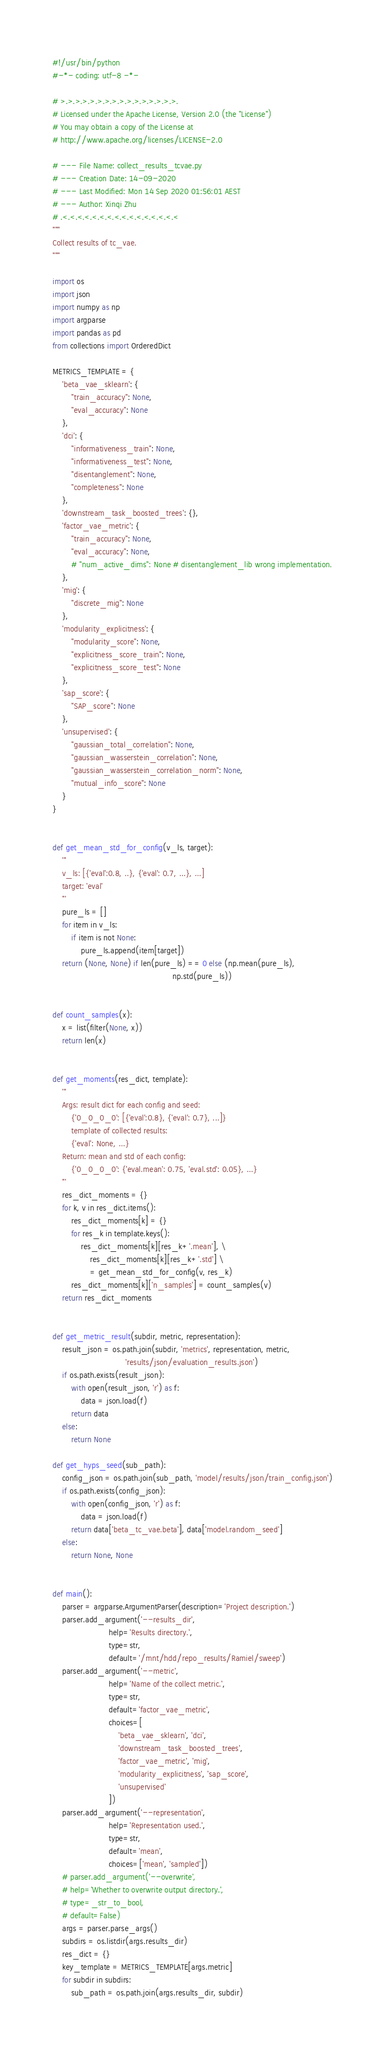Convert code to text. <code><loc_0><loc_0><loc_500><loc_500><_Python_>#!/usr/bin/python
#-*- coding: utf-8 -*-

# >.>.>.>.>.>.>.>.>.>.>.>.>.>.>.>.
# Licensed under the Apache License, Version 2.0 (the "License")
# You may obtain a copy of the License at
# http://www.apache.org/licenses/LICENSE-2.0

# --- File Name: collect_results_tcvae.py
# --- Creation Date: 14-09-2020
# --- Last Modified: Mon 14 Sep 2020 01:56:01 AEST
# --- Author: Xinqi Zhu
# .<.<.<.<.<.<.<.<.<.<.<.<.<.<.<.<
"""
Collect results of tc_vae.
"""

import os
import json
import numpy as np
import argparse
import pandas as pd
from collections import OrderedDict

METRICS_TEMPLATE = {
    'beta_vae_sklearn': {
        "train_accuracy": None,
        "eval_accuracy": None
    },
    'dci': {
        "informativeness_train": None,
        "informativeness_test": None,
        "disentanglement": None,
        "completeness": None
    },
    'downstream_task_boosted_trees': {},
    'factor_vae_metric': {
        "train_accuracy": None,
        "eval_accuracy": None,
        # "num_active_dims": None # disentanglement_lib wrong implementation.
    },
    'mig': {
        "discrete_mig": None
    },
    'modularity_explicitness': {
        "modularity_score": None,
        "explicitness_score_train": None,
        "explicitness_score_test": None
    },
    'sap_score': {
        "SAP_score": None
    },
    'unsupervised': {
        "gaussian_total_correlation": None,
        "gaussian_wasserstein_correlation": None,
        "gaussian_wasserstein_correlation_norm": None,
        "mutual_info_score": None
    }
}


def get_mean_std_for_config(v_ls, target):
    '''
    v_ls: [{'eval':0.8, ..}, {'eval': 0.7, ...}, ...]
    target: 'eval'
    '''
    pure_ls = []
    for item in v_ls:
        if item is not None:
            pure_ls.append(item[target])
    return (None, None) if len(pure_ls) == 0 else (np.mean(pure_ls),
                                                   np.std(pure_ls))


def count_samples(x):
    x = list(filter(None, x))
    return len(x)


def get_moments(res_dict, template):
    '''
    Args: result dict for each config and seed:
        {'0_0_0_0': [{'eval':0.8}, {'eval': 0.7}, ...]}
        template of collected results:
        {'eval': None, ...}
    Return: mean and std of each config:
        {'0_0_0_0': {'eval.mean': 0.75, 'eval.std': 0.05}, ...}
    '''
    res_dict_moments = {}
    for k, v in res_dict.items():
        res_dict_moments[k] = {}
        for res_k in template.keys():
            res_dict_moments[k][res_k+'.mean'], \
                res_dict_moments[k][res_k+'.std'] \
                = get_mean_std_for_config(v, res_k)
        res_dict_moments[k]['n_samples'] = count_samples(v)
    return res_dict_moments


def get_metric_result(subdir, metric, representation):
    result_json = os.path.join(subdir, 'metrics', representation, metric,
                               'results/json/evaluation_results.json')
    if os.path.exists(result_json):
        with open(result_json, 'r') as f:
            data = json.load(f)
        return data
    else:
        return None

def get_hyps_seed(sub_path):
    config_json = os.path.join(sub_path, 'model/results/json/train_config.json')
    if os.path.exists(config_json):
        with open(config_json, 'r') as f:
            data = json.load(f)
        return data['beta_tc_vae.beta'], data['model.random_seed']
    else:
        return None, None


def main():
    parser = argparse.ArgumentParser(description='Project description.')
    parser.add_argument('--results_dir',
                        help='Results directory.',
                        type=str,
                        default='/mnt/hdd/repo_results/Ramiel/sweep')
    parser.add_argument('--metric',
                        help='Name of the collect metric.',
                        type=str,
                        default='factor_vae_metric',
                        choices=[
                            'beta_vae_sklearn', 'dci',
                            'downstream_task_boosted_trees',
                            'factor_vae_metric', 'mig',
                            'modularity_explicitness', 'sap_score',
                            'unsupervised'
                        ])
    parser.add_argument('--representation',
                        help='Representation used.',
                        type=str,
                        default='mean',
                        choices=['mean', 'sampled'])
    # parser.add_argument('--overwrite',
    # help='Whether to overwrite output directory.',
    # type=_str_to_bool,
    # default=False)
    args = parser.parse_args()
    subdirs = os.listdir(args.results_dir)
    res_dict = {}
    key_template = METRICS_TEMPLATE[args.metric]
    for subdir in subdirs:
        sub_path = os.path.join(args.results_dir, subdir)</code> 